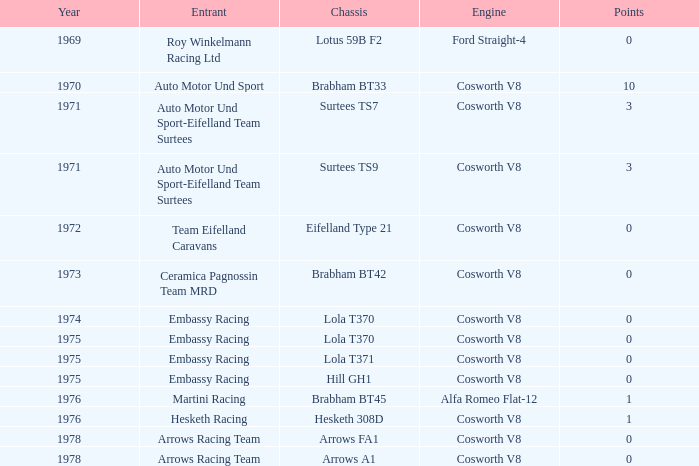Would you mind parsing the complete table? {'header': ['Year', 'Entrant', 'Chassis', 'Engine', 'Points'], 'rows': [['1969', 'Roy Winkelmann Racing Ltd', 'Lotus 59B F2', 'Ford Straight-4', '0'], ['1970', 'Auto Motor Und Sport', 'Brabham BT33', 'Cosworth V8', '10'], ['1971', 'Auto Motor Und Sport-Eifelland Team Surtees', 'Surtees TS7', 'Cosworth V8', '3'], ['1971', 'Auto Motor Und Sport-Eifelland Team Surtees', 'Surtees TS9', 'Cosworth V8', '3'], ['1972', 'Team Eifelland Caravans', 'Eifelland Type 21', 'Cosworth V8', '0'], ['1973', 'Ceramica Pagnossin Team MRD', 'Brabham BT42', 'Cosworth V8', '0'], ['1974', 'Embassy Racing', 'Lola T370', 'Cosworth V8', '0'], ['1975', 'Embassy Racing', 'Lola T370', 'Cosworth V8', '0'], ['1975', 'Embassy Racing', 'Lola T371', 'Cosworth V8', '0'], ['1975', 'Embassy Racing', 'Hill GH1', 'Cosworth V8', '0'], ['1976', 'Martini Racing', 'Brabham BT45', 'Alfa Romeo Flat-12', '1'], ['1976', 'Hesketh Racing', 'Hesketh 308D', 'Cosworth V8', '1'], ['1978', 'Arrows Racing Team', 'Arrows FA1', 'Cosworth V8', '0'], ['1978', 'Arrows Racing Team', 'Arrows A1', 'Cosworth V8', '0']]} Who participated in the 1971 event? Auto Motor Und Sport-Eifelland Team Surtees, Auto Motor Und Sport-Eifelland Team Surtees. 